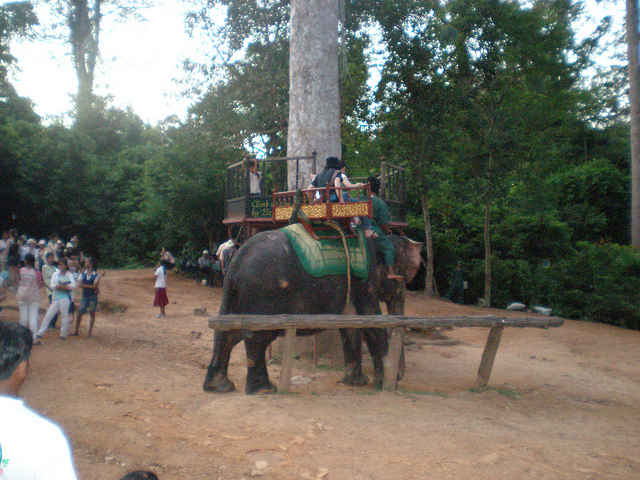<image>Does the canopy top give off shade? I am not sure if the canopy top gives off shade. It can be yes or no. Does the canopy top give off shade? I don't know if the canopy top gives off shade. 